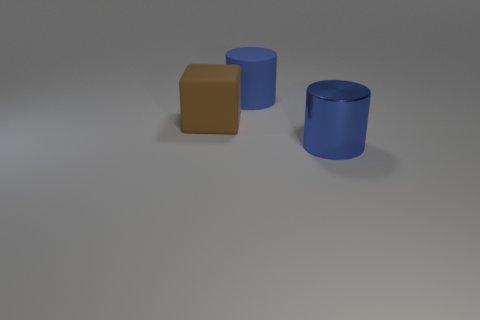The other cylinder that is the same color as the rubber cylinder is what size?
Ensure brevity in your answer.  Large. There is a blue cylinder that is to the left of the large metallic cylinder that is in front of the block; what is its size?
Offer a very short reply. Large. Are there an equal number of blue metallic cylinders on the left side of the blue shiny thing and large gray cylinders?
Ensure brevity in your answer.  Yes. What number of other objects are the same color as the rubber block?
Offer a very short reply. 0. Are there fewer objects in front of the big shiny cylinder than big blue shiny things?
Provide a short and direct response. Yes. Are there any blue objects of the same size as the rubber cube?
Give a very brief answer. Yes. There is a large block; is its color the same as the cylinder that is left of the large metal thing?
Your answer should be very brief. No. How many large blue matte cylinders are to the right of the large cylinder that is behind the big metallic cylinder?
Your answer should be compact. 0. There is a large rubber object that is to the left of the blue object behind the big shiny cylinder; what color is it?
Offer a terse response. Brown. What is the thing that is both in front of the big blue rubber cylinder and behind the big blue shiny cylinder made of?
Your response must be concise. Rubber. 